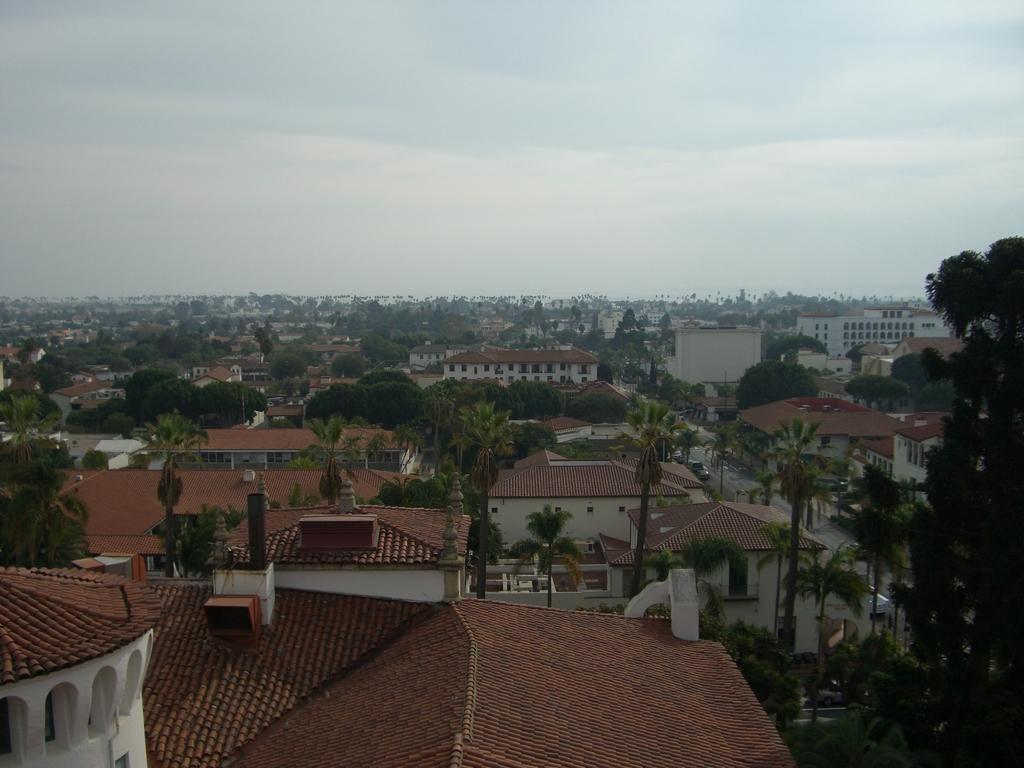How would you summarize this image in a sentence or two? In this picture we can observe some houses and trees. There are some buildings. In the background there is a sky with some clouds. 